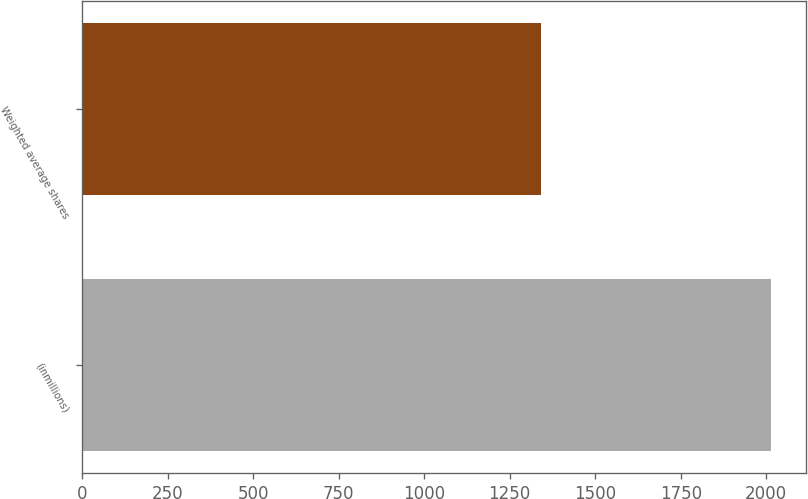<chart> <loc_0><loc_0><loc_500><loc_500><bar_chart><fcel>(inmillions)<fcel>Weighted average shares<nl><fcel>2015<fcel>1341.2<nl></chart> 